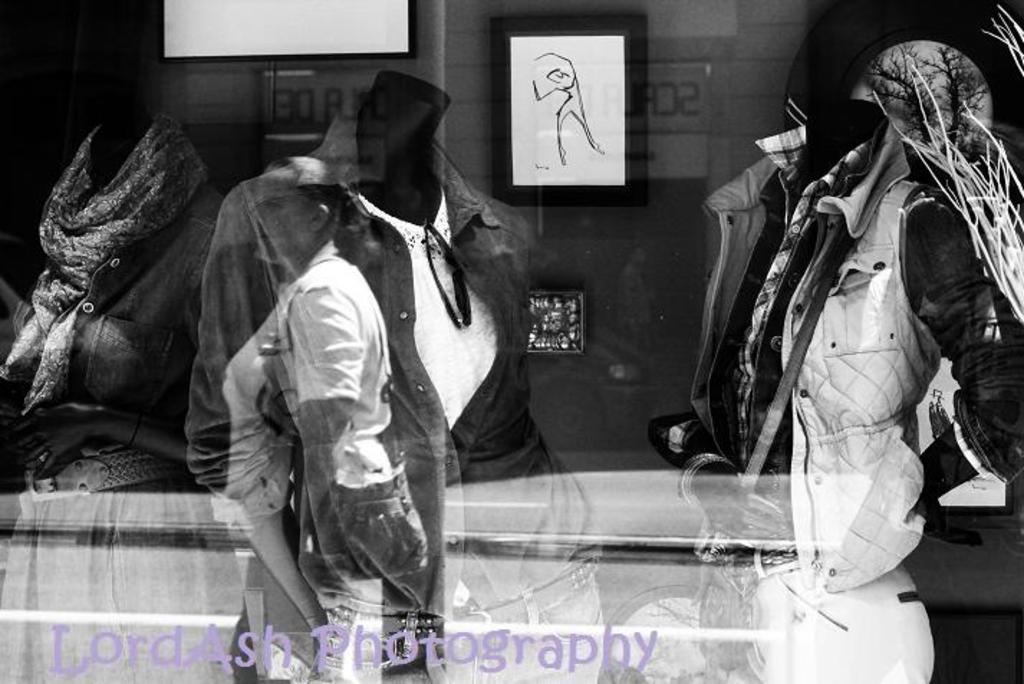Describe this image in one or two sentences. As we can see in the image there is a reflection of few people and a building. 